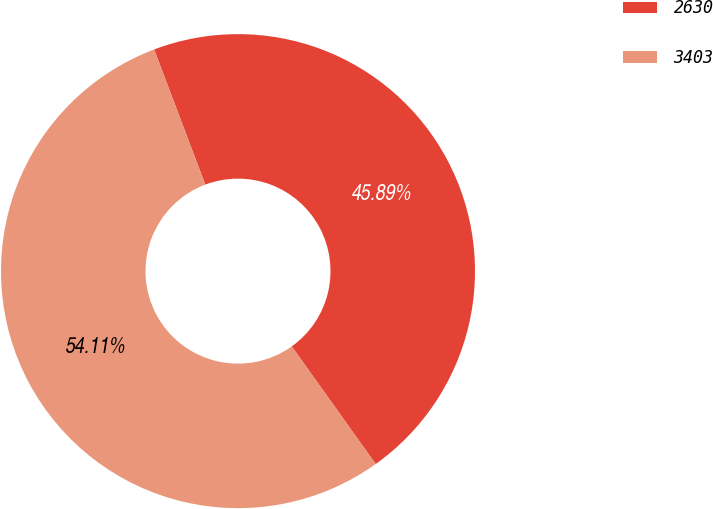Convert chart to OTSL. <chart><loc_0><loc_0><loc_500><loc_500><pie_chart><fcel>2630<fcel>3403<nl><fcel>45.89%<fcel>54.11%<nl></chart> 